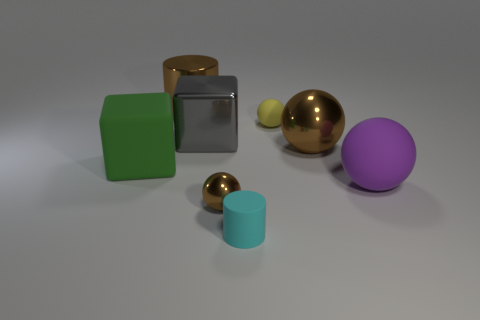Subtract all large shiny spheres. How many spheres are left? 3 Subtract 1 balls. How many balls are left? 3 Subtract all green cylinders. How many brown balls are left? 2 Subtract all purple spheres. How many spheres are left? 3 Add 1 brown rubber cylinders. How many objects exist? 9 Add 2 cyan metallic balls. How many cyan metallic balls exist? 2 Subtract 0 gray cylinders. How many objects are left? 8 Subtract all cubes. How many objects are left? 6 Subtract all brown blocks. Subtract all green balls. How many blocks are left? 2 Subtract all big red matte cylinders. Subtract all small brown spheres. How many objects are left? 7 